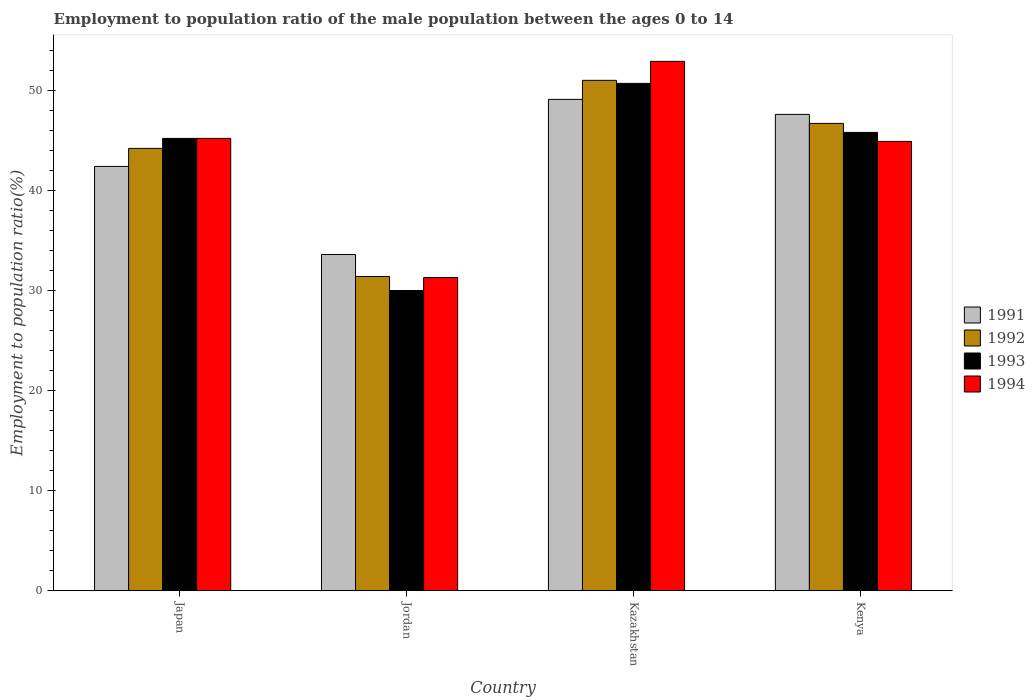How many bars are there on the 4th tick from the left?
Your answer should be compact. 4. What is the label of the 2nd group of bars from the left?
Ensure brevity in your answer.  Jordan. What is the employment to population ratio in 1992 in Japan?
Give a very brief answer. 44.2. Across all countries, what is the minimum employment to population ratio in 1992?
Offer a terse response. 31.4. In which country was the employment to population ratio in 1994 maximum?
Give a very brief answer. Kazakhstan. In which country was the employment to population ratio in 1993 minimum?
Your response must be concise. Jordan. What is the total employment to population ratio in 1991 in the graph?
Ensure brevity in your answer.  172.7. What is the difference between the employment to population ratio in 1991 in Japan and that in Jordan?
Your answer should be very brief. 8.8. What is the average employment to population ratio in 1994 per country?
Make the answer very short. 43.58. What is the difference between the employment to population ratio of/in 1993 and employment to population ratio of/in 1994 in Kenya?
Provide a succinct answer. 0.9. In how many countries, is the employment to population ratio in 1993 greater than 42 %?
Offer a very short reply. 3. What is the ratio of the employment to population ratio in 1992 in Japan to that in Jordan?
Ensure brevity in your answer.  1.41. Is the employment to population ratio in 1994 in Kazakhstan less than that in Kenya?
Your answer should be compact. No. Is the difference between the employment to population ratio in 1993 in Japan and Kenya greater than the difference between the employment to population ratio in 1994 in Japan and Kenya?
Your answer should be very brief. No. What is the difference between the highest and the second highest employment to population ratio in 1992?
Your answer should be very brief. 6.8. What is the difference between the highest and the lowest employment to population ratio in 1992?
Ensure brevity in your answer.  19.6. Is the sum of the employment to population ratio in 1991 in Kazakhstan and Kenya greater than the maximum employment to population ratio in 1994 across all countries?
Ensure brevity in your answer.  Yes. Is it the case that in every country, the sum of the employment to population ratio in 1993 and employment to population ratio in 1994 is greater than the sum of employment to population ratio in 1992 and employment to population ratio in 1991?
Offer a terse response. No. What does the 2nd bar from the right in Jordan represents?
Offer a very short reply. 1993. Are all the bars in the graph horizontal?
Give a very brief answer. No. How many countries are there in the graph?
Your answer should be very brief. 4. Does the graph contain any zero values?
Keep it short and to the point. No. Where does the legend appear in the graph?
Provide a succinct answer. Center right. How many legend labels are there?
Your answer should be very brief. 4. What is the title of the graph?
Offer a terse response. Employment to population ratio of the male population between the ages 0 to 14. Does "2012" appear as one of the legend labels in the graph?
Ensure brevity in your answer.  No. What is the label or title of the X-axis?
Provide a succinct answer. Country. What is the label or title of the Y-axis?
Your answer should be very brief. Employment to population ratio(%). What is the Employment to population ratio(%) of 1991 in Japan?
Provide a short and direct response. 42.4. What is the Employment to population ratio(%) of 1992 in Japan?
Give a very brief answer. 44.2. What is the Employment to population ratio(%) in 1993 in Japan?
Provide a short and direct response. 45.2. What is the Employment to population ratio(%) of 1994 in Japan?
Make the answer very short. 45.2. What is the Employment to population ratio(%) of 1991 in Jordan?
Ensure brevity in your answer.  33.6. What is the Employment to population ratio(%) of 1992 in Jordan?
Your answer should be compact. 31.4. What is the Employment to population ratio(%) of 1993 in Jordan?
Your answer should be very brief. 30. What is the Employment to population ratio(%) in 1994 in Jordan?
Make the answer very short. 31.3. What is the Employment to population ratio(%) in 1991 in Kazakhstan?
Ensure brevity in your answer.  49.1. What is the Employment to population ratio(%) in 1992 in Kazakhstan?
Your response must be concise. 51. What is the Employment to population ratio(%) in 1993 in Kazakhstan?
Make the answer very short. 50.7. What is the Employment to population ratio(%) of 1994 in Kazakhstan?
Your answer should be very brief. 52.9. What is the Employment to population ratio(%) of 1991 in Kenya?
Keep it short and to the point. 47.6. What is the Employment to population ratio(%) in 1992 in Kenya?
Your response must be concise. 46.7. What is the Employment to population ratio(%) of 1993 in Kenya?
Provide a succinct answer. 45.8. What is the Employment to population ratio(%) in 1994 in Kenya?
Provide a succinct answer. 44.9. Across all countries, what is the maximum Employment to population ratio(%) in 1991?
Ensure brevity in your answer.  49.1. Across all countries, what is the maximum Employment to population ratio(%) of 1993?
Ensure brevity in your answer.  50.7. Across all countries, what is the maximum Employment to population ratio(%) in 1994?
Give a very brief answer. 52.9. Across all countries, what is the minimum Employment to population ratio(%) in 1991?
Your answer should be very brief. 33.6. Across all countries, what is the minimum Employment to population ratio(%) in 1992?
Give a very brief answer. 31.4. Across all countries, what is the minimum Employment to population ratio(%) of 1993?
Your response must be concise. 30. Across all countries, what is the minimum Employment to population ratio(%) of 1994?
Make the answer very short. 31.3. What is the total Employment to population ratio(%) in 1991 in the graph?
Your answer should be very brief. 172.7. What is the total Employment to population ratio(%) in 1992 in the graph?
Give a very brief answer. 173.3. What is the total Employment to population ratio(%) in 1993 in the graph?
Offer a terse response. 171.7. What is the total Employment to population ratio(%) in 1994 in the graph?
Provide a short and direct response. 174.3. What is the difference between the Employment to population ratio(%) in 1992 in Japan and that in Jordan?
Ensure brevity in your answer.  12.8. What is the difference between the Employment to population ratio(%) of 1993 in Japan and that in Jordan?
Provide a succinct answer. 15.2. What is the difference between the Employment to population ratio(%) in 1994 in Japan and that in Jordan?
Your answer should be compact. 13.9. What is the difference between the Employment to population ratio(%) of 1992 in Japan and that in Kazakhstan?
Your answer should be compact. -6.8. What is the difference between the Employment to population ratio(%) of 1994 in Japan and that in Kazakhstan?
Provide a short and direct response. -7.7. What is the difference between the Employment to population ratio(%) of 1991 in Japan and that in Kenya?
Your answer should be compact. -5.2. What is the difference between the Employment to population ratio(%) in 1992 in Japan and that in Kenya?
Your answer should be compact. -2.5. What is the difference between the Employment to population ratio(%) of 1991 in Jordan and that in Kazakhstan?
Your answer should be very brief. -15.5. What is the difference between the Employment to population ratio(%) in 1992 in Jordan and that in Kazakhstan?
Your answer should be compact. -19.6. What is the difference between the Employment to population ratio(%) in 1993 in Jordan and that in Kazakhstan?
Provide a succinct answer. -20.7. What is the difference between the Employment to population ratio(%) in 1994 in Jordan and that in Kazakhstan?
Provide a succinct answer. -21.6. What is the difference between the Employment to population ratio(%) in 1992 in Jordan and that in Kenya?
Provide a short and direct response. -15.3. What is the difference between the Employment to population ratio(%) in 1993 in Jordan and that in Kenya?
Make the answer very short. -15.8. What is the difference between the Employment to population ratio(%) in 1991 in Kazakhstan and that in Kenya?
Offer a very short reply. 1.5. What is the difference between the Employment to population ratio(%) in 1993 in Kazakhstan and that in Kenya?
Offer a very short reply. 4.9. What is the difference between the Employment to population ratio(%) of 1994 in Kazakhstan and that in Kenya?
Ensure brevity in your answer.  8. What is the difference between the Employment to population ratio(%) of 1993 in Japan and the Employment to population ratio(%) of 1994 in Jordan?
Ensure brevity in your answer.  13.9. What is the difference between the Employment to population ratio(%) of 1991 in Japan and the Employment to population ratio(%) of 1993 in Kazakhstan?
Provide a succinct answer. -8.3. What is the difference between the Employment to population ratio(%) of 1992 in Japan and the Employment to population ratio(%) of 1993 in Kazakhstan?
Your answer should be very brief. -6.5. What is the difference between the Employment to population ratio(%) in 1991 in Japan and the Employment to population ratio(%) in 1993 in Kenya?
Give a very brief answer. -3.4. What is the difference between the Employment to population ratio(%) of 1991 in Japan and the Employment to population ratio(%) of 1994 in Kenya?
Keep it short and to the point. -2.5. What is the difference between the Employment to population ratio(%) in 1991 in Jordan and the Employment to population ratio(%) in 1992 in Kazakhstan?
Provide a succinct answer. -17.4. What is the difference between the Employment to population ratio(%) in 1991 in Jordan and the Employment to population ratio(%) in 1993 in Kazakhstan?
Offer a terse response. -17.1. What is the difference between the Employment to population ratio(%) in 1991 in Jordan and the Employment to population ratio(%) in 1994 in Kazakhstan?
Provide a short and direct response. -19.3. What is the difference between the Employment to population ratio(%) of 1992 in Jordan and the Employment to population ratio(%) of 1993 in Kazakhstan?
Ensure brevity in your answer.  -19.3. What is the difference between the Employment to population ratio(%) of 1992 in Jordan and the Employment to population ratio(%) of 1994 in Kazakhstan?
Offer a terse response. -21.5. What is the difference between the Employment to population ratio(%) of 1993 in Jordan and the Employment to population ratio(%) of 1994 in Kazakhstan?
Your answer should be compact. -22.9. What is the difference between the Employment to population ratio(%) of 1991 in Jordan and the Employment to population ratio(%) of 1993 in Kenya?
Provide a succinct answer. -12.2. What is the difference between the Employment to population ratio(%) of 1991 in Jordan and the Employment to population ratio(%) of 1994 in Kenya?
Make the answer very short. -11.3. What is the difference between the Employment to population ratio(%) of 1992 in Jordan and the Employment to population ratio(%) of 1993 in Kenya?
Provide a succinct answer. -14.4. What is the difference between the Employment to population ratio(%) of 1992 in Jordan and the Employment to population ratio(%) of 1994 in Kenya?
Your answer should be compact. -13.5. What is the difference between the Employment to population ratio(%) of 1993 in Jordan and the Employment to population ratio(%) of 1994 in Kenya?
Give a very brief answer. -14.9. What is the difference between the Employment to population ratio(%) of 1992 in Kazakhstan and the Employment to population ratio(%) of 1994 in Kenya?
Give a very brief answer. 6.1. What is the difference between the Employment to population ratio(%) of 1993 in Kazakhstan and the Employment to population ratio(%) of 1994 in Kenya?
Ensure brevity in your answer.  5.8. What is the average Employment to population ratio(%) in 1991 per country?
Your answer should be compact. 43.17. What is the average Employment to population ratio(%) in 1992 per country?
Your answer should be compact. 43.33. What is the average Employment to population ratio(%) in 1993 per country?
Keep it short and to the point. 42.92. What is the average Employment to population ratio(%) in 1994 per country?
Give a very brief answer. 43.58. What is the difference between the Employment to population ratio(%) in 1991 and Employment to population ratio(%) in 1992 in Japan?
Provide a succinct answer. -1.8. What is the difference between the Employment to population ratio(%) in 1991 and Employment to population ratio(%) in 1993 in Japan?
Offer a very short reply. -2.8. What is the difference between the Employment to population ratio(%) in 1992 and Employment to population ratio(%) in 1993 in Japan?
Give a very brief answer. -1. What is the difference between the Employment to population ratio(%) of 1991 and Employment to population ratio(%) of 1992 in Jordan?
Provide a succinct answer. 2.2. What is the difference between the Employment to population ratio(%) of 1991 and Employment to population ratio(%) of 1993 in Jordan?
Ensure brevity in your answer.  3.6. What is the difference between the Employment to population ratio(%) in 1991 and Employment to population ratio(%) in 1994 in Jordan?
Your answer should be very brief. 2.3. What is the difference between the Employment to population ratio(%) of 1992 and Employment to population ratio(%) of 1993 in Jordan?
Give a very brief answer. 1.4. What is the difference between the Employment to population ratio(%) of 1992 and Employment to population ratio(%) of 1994 in Jordan?
Your answer should be very brief. 0.1. What is the difference between the Employment to population ratio(%) of 1993 and Employment to population ratio(%) of 1994 in Jordan?
Make the answer very short. -1.3. What is the difference between the Employment to population ratio(%) in 1991 and Employment to population ratio(%) in 1992 in Kazakhstan?
Keep it short and to the point. -1.9. What is the difference between the Employment to population ratio(%) of 1991 and Employment to population ratio(%) of 1993 in Kenya?
Provide a short and direct response. 1.8. What is the difference between the Employment to population ratio(%) in 1991 and Employment to population ratio(%) in 1994 in Kenya?
Your response must be concise. 2.7. What is the difference between the Employment to population ratio(%) of 1992 and Employment to population ratio(%) of 1993 in Kenya?
Provide a short and direct response. 0.9. What is the ratio of the Employment to population ratio(%) of 1991 in Japan to that in Jordan?
Provide a succinct answer. 1.26. What is the ratio of the Employment to population ratio(%) in 1992 in Japan to that in Jordan?
Provide a short and direct response. 1.41. What is the ratio of the Employment to population ratio(%) of 1993 in Japan to that in Jordan?
Provide a short and direct response. 1.51. What is the ratio of the Employment to population ratio(%) in 1994 in Japan to that in Jordan?
Make the answer very short. 1.44. What is the ratio of the Employment to population ratio(%) in 1991 in Japan to that in Kazakhstan?
Keep it short and to the point. 0.86. What is the ratio of the Employment to population ratio(%) in 1992 in Japan to that in Kazakhstan?
Your answer should be very brief. 0.87. What is the ratio of the Employment to population ratio(%) in 1993 in Japan to that in Kazakhstan?
Offer a very short reply. 0.89. What is the ratio of the Employment to population ratio(%) in 1994 in Japan to that in Kazakhstan?
Provide a short and direct response. 0.85. What is the ratio of the Employment to population ratio(%) of 1991 in Japan to that in Kenya?
Offer a terse response. 0.89. What is the ratio of the Employment to population ratio(%) in 1992 in Japan to that in Kenya?
Provide a succinct answer. 0.95. What is the ratio of the Employment to population ratio(%) of 1993 in Japan to that in Kenya?
Offer a terse response. 0.99. What is the ratio of the Employment to population ratio(%) in 1994 in Japan to that in Kenya?
Provide a succinct answer. 1.01. What is the ratio of the Employment to population ratio(%) in 1991 in Jordan to that in Kazakhstan?
Offer a very short reply. 0.68. What is the ratio of the Employment to population ratio(%) in 1992 in Jordan to that in Kazakhstan?
Give a very brief answer. 0.62. What is the ratio of the Employment to population ratio(%) of 1993 in Jordan to that in Kazakhstan?
Ensure brevity in your answer.  0.59. What is the ratio of the Employment to population ratio(%) in 1994 in Jordan to that in Kazakhstan?
Make the answer very short. 0.59. What is the ratio of the Employment to population ratio(%) of 1991 in Jordan to that in Kenya?
Offer a terse response. 0.71. What is the ratio of the Employment to population ratio(%) in 1992 in Jordan to that in Kenya?
Offer a terse response. 0.67. What is the ratio of the Employment to population ratio(%) in 1993 in Jordan to that in Kenya?
Your response must be concise. 0.66. What is the ratio of the Employment to population ratio(%) of 1994 in Jordan to that in Kenya?
Ensure brevity in your answer.  0.7. What is the ratio of the Employment to population ratio(%) of 1991 in Kazakhstan to that in Kenya?
Keep it short and to the point. 1.03. What is the ratio of the Employment to population ratio(%) in 1992 in Kazakhstan to that in Kenya?
Keep it short and to the point. 1.09. What is the ratio of the Employment to population ratio(%) of 1993 in Kazakhstan to that in Kenya?
Offer a terse response. 1.11. What is the ratio of the Employment to population ratio(%) of 1994 in Kazakhstan to that in Kenya?
Provide a succinct answer. 1.18. What is the difference between the highest and the second highest Employment to population ratio(%) in 1992?
Your answer should be very brief. 4.3. What is the difference between the highest and the lowest Employment to population ratio(%) of 1991?
Ensure brevity in your answer.  15.5. What is the difference between the highest and the lowest Employment to population ratio(%) in 1992?
Offer a terse response. 19.6. What is the difference between the highest and the lowest Employment to population ratio(%) in 1993?
Your response must be concise. 20.7. What is the difference between the highest and the lowest Employment to population ratio(%) in 1994?
Offer a terse response. 21.6. 